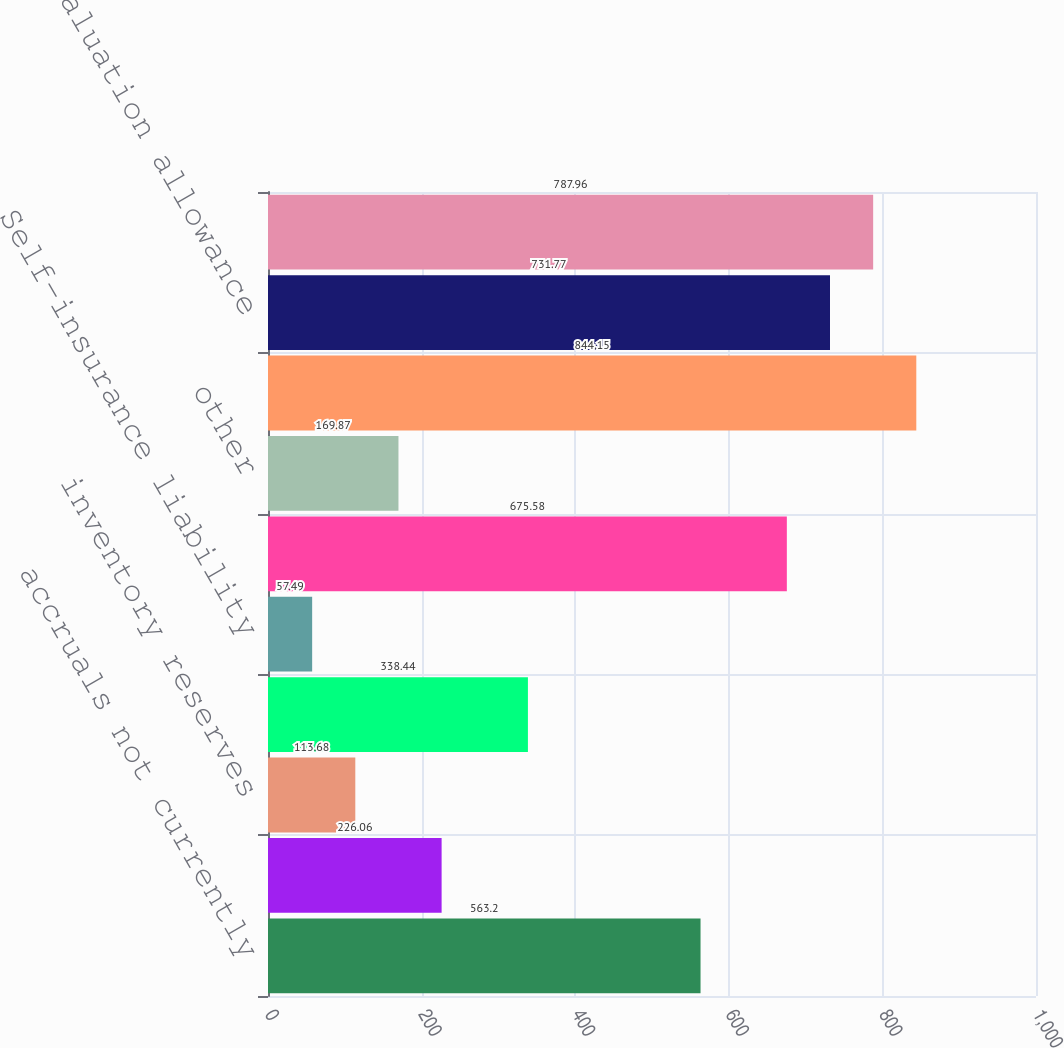Convert chart to OTSL. <chart><loc_0><loc_0><loc_500><loc_500><bar_chart><fcel>accruals not currently<fcel>Postretirement liabilities<fcel>inventory reserves<fcel>Pension liabilities<fcel>Self-insurance liability<fcel>Foreign net operating losses<fcel>other<fcel>total gross deferred tax<fcel>less valuation allowance<fcel>net deferred tax assets after<nl><fcel>563.2<fcel>226.06<fcel>113.68<fcel>338.44<fcel>57.49<fcel>675.58<fcel>169.87<fcel>844.15<fcel>731.77<fcel>787.96<nl></chart> 